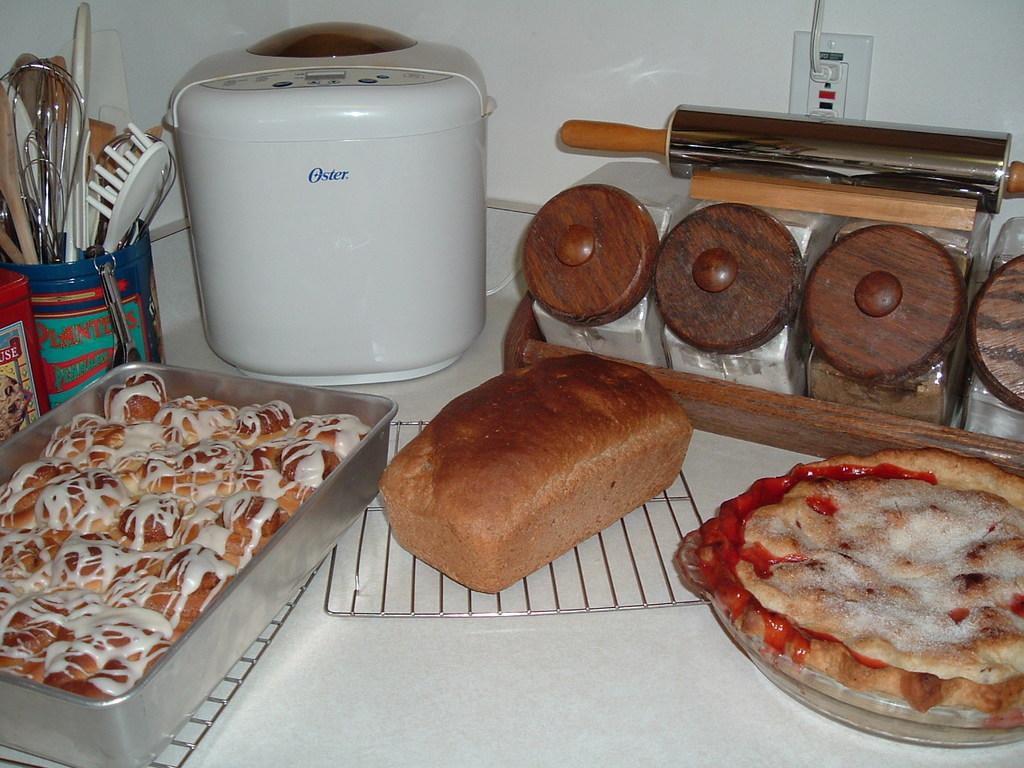What is the brand name on the appliance?
Provide a succinct answer. Oster. What brand of bread maker is this?
Ensure brevity in your answer.  Oster. 